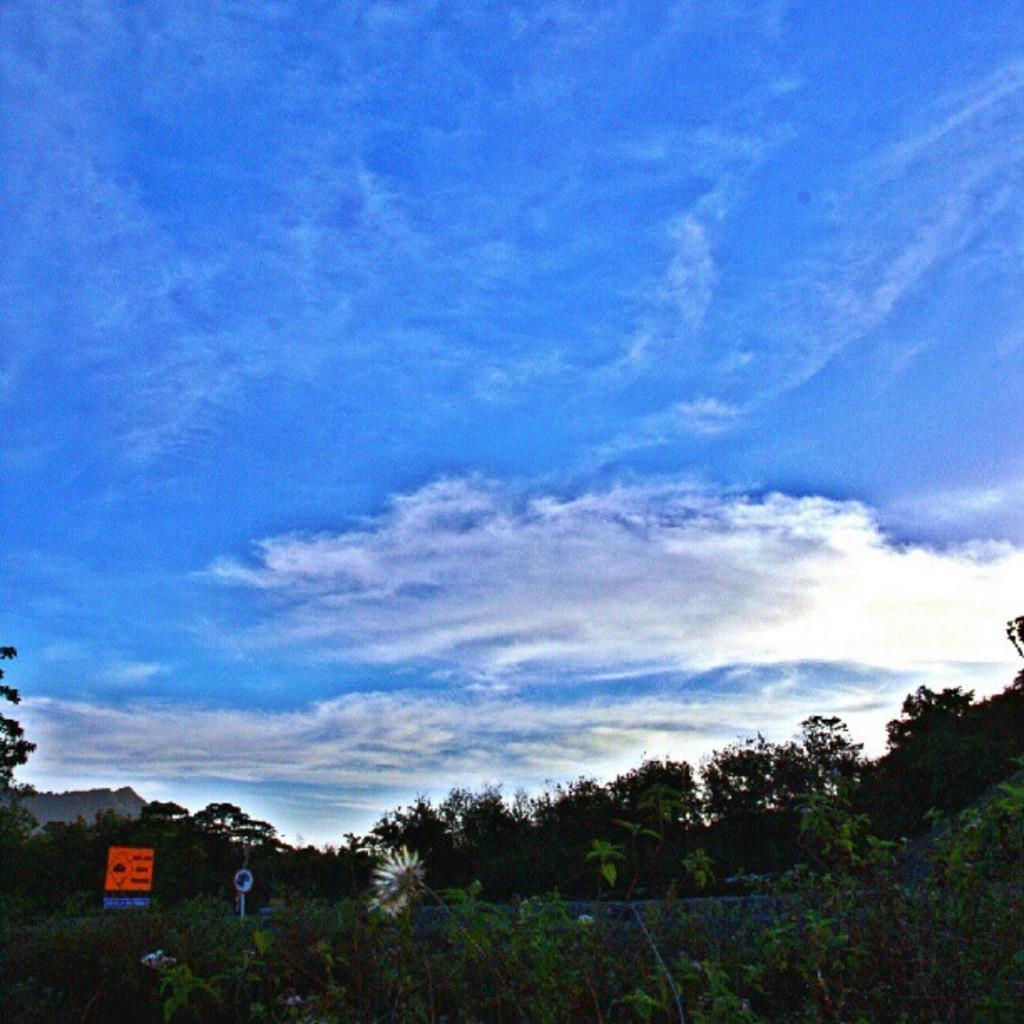Describe this image in one or two sentences. In this picture we can see trees and we can see sky in the background. 